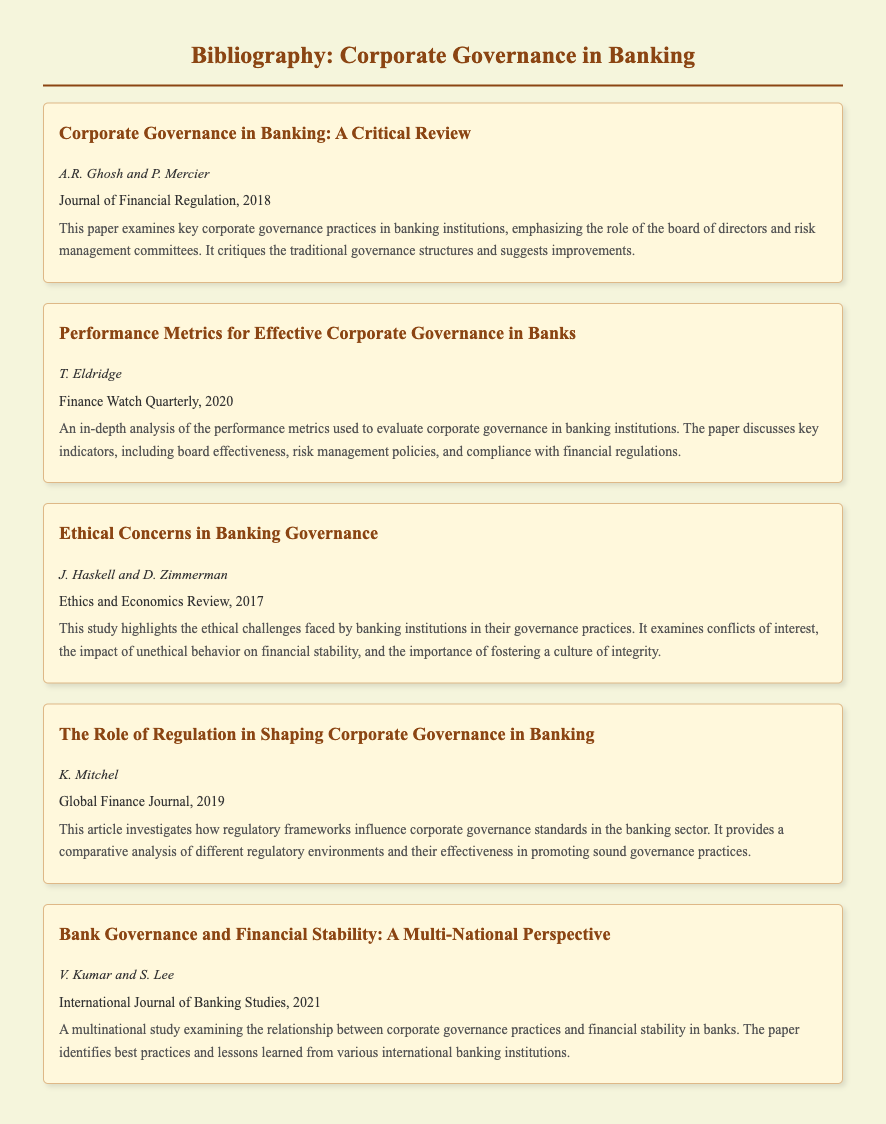What is the title of the first item? The title is the main heading of the first bibliography item, which is "Corporate Governance in Banking: A Critical Review".
Answer: Corporate Governance in Banking: A Critical Review Who are the authors of the second item? The authors are listed immediately below the title of the second bibliography item, which are "T. Eldridge".
Answer: T. Eldridge In which year was the article by J. Haskell and D. Zimmerman published? The publication year is stated in the entry for the third bibliography item, which is "2017".
Answer: 2017 How many items are listed in the bibliography? The number of bibliography items can be counted from the document, which has a total of five items.
Answer: 5 What journal published the article analyzing performance metrics? The journal name is indicated in the second bibliography item, which is "Finance Watch Quarterly".
Answer: Finance Watch Quarterly What ethical concern is mentioned in the third entry? The specific concern is indicated in the abstract of the third item, which highlights "conflicts of interest".
Answer: conflicts of interest What does the article by K. Mitchel discuss? The focus of the article is indicated in the abstract, which discusses how "regulatory frameworks influence corporate governance standards".
Answer: regulatory frameworks influence corporate governance standards Which journal featured the item on financial stability and governance practices? The journal name is mentioned in the fifth item, which is "International Journal of Banking Studies".
Answer: International Journal of Banking Studies What is the primary focus of V. Kumar and S. Lee's study? The primary focus is described in the title and abstract of the fifth item, which is "the relationship between corporate governance practices and financial stability".
Answer: relationship between corporate governance practices and financial stability 